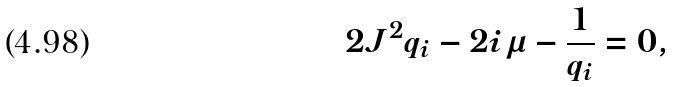Convert formula to latex. <formula><loc_0><loc_0><loc_500><loc_500>2 J ^ { 2 } q _ { i } - 2 i \mu - \frac { 1 } { q _ { i } } = 0 ,</formula> 